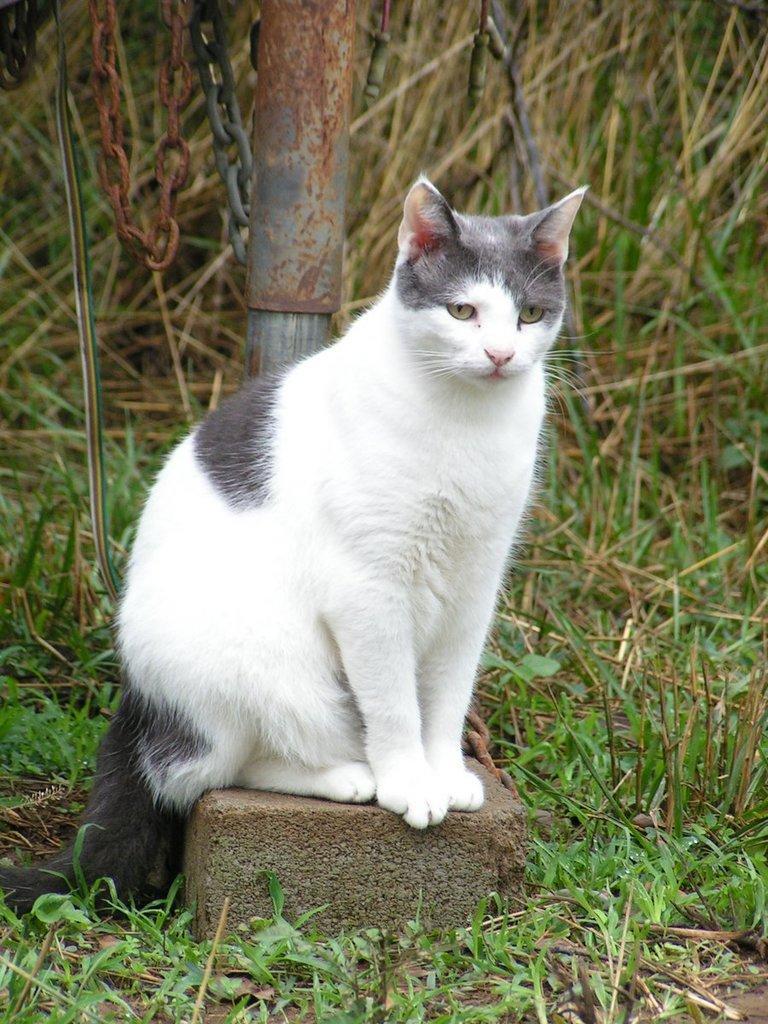Can you describe this image briefly? In the middle of this image, there is a white color cat on a brick. This brick is placed on a ground on which there is grass. In the background, there is grass, a pole and a chain. 